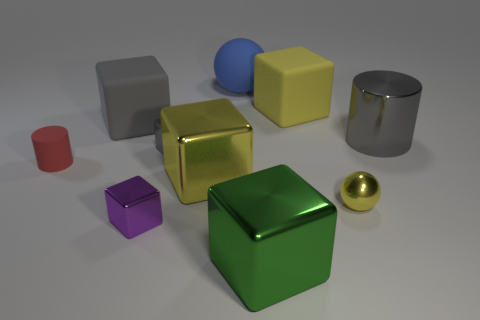Can you describe the lighting direction in the scene? The lighting in the scene appears to be coming from the upper left side. This is indicated by the shadows cast towards the lower right of the objects, and the brightly lit left sides of the objects which suggest a single, diffuse light source in that direction. 